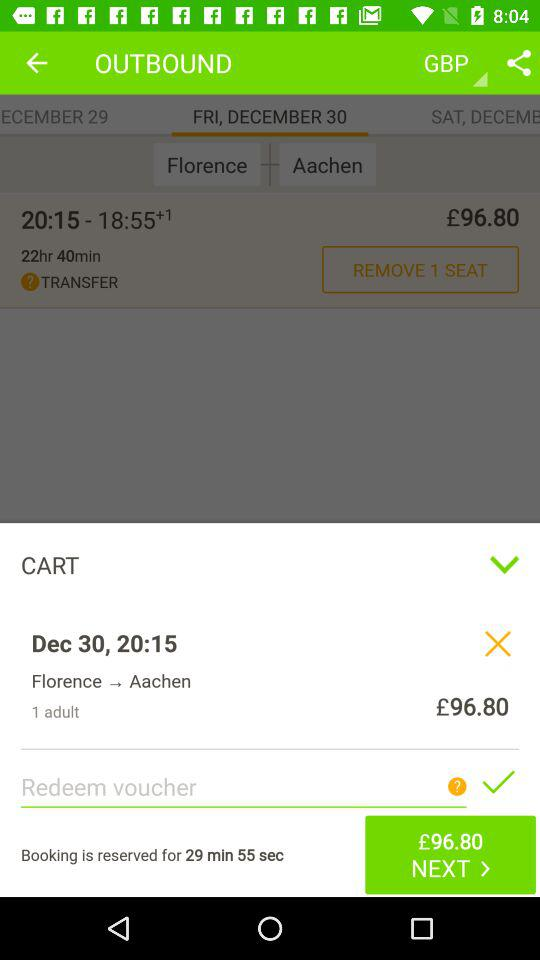What is the duration of a reserved booking? The duration is 29 minutes and 55 seconds. 